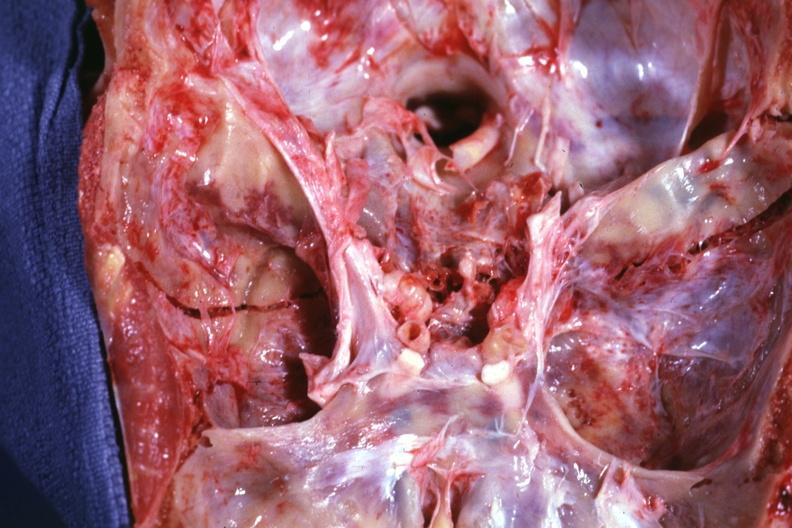s basal skull fracture present?
Answer the question using a single word or phrase. Yes 